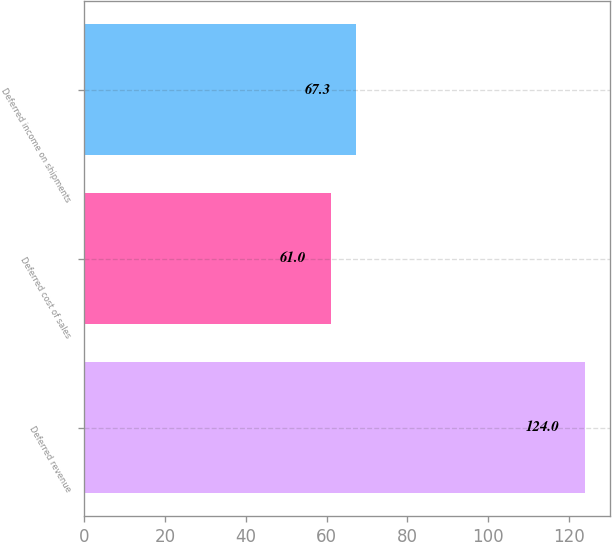Convert chart to OTSL. <chart><loc_0><loc_0><loc_500><loc_500><bar_chart><fcel>Deferred revenue<fcel>Deferred cost of sales<fcel>Deferred income on shipments<nl><fcel>124<fcel>61<fcel>67.3<nl></chart> 